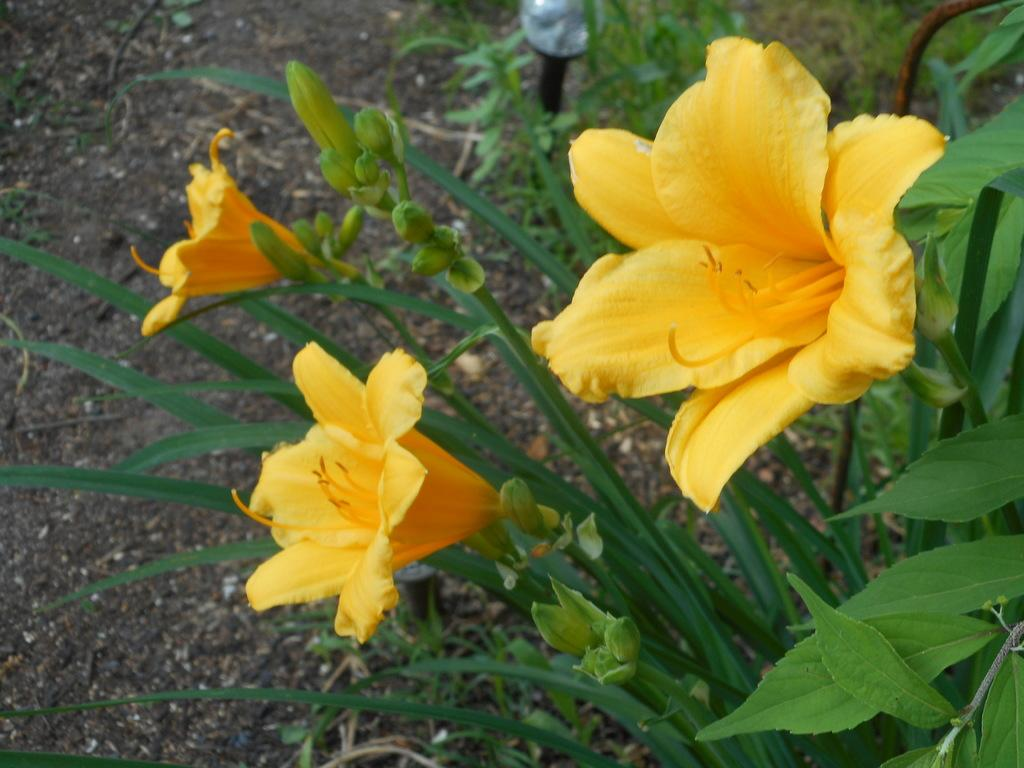What type of plants can be seen in the image? There are flowers in the image. What color are the flowers? The flowers are yellow. What other part of the plant is visible in the image? There are green leaves in the image. What type of camera is being used to take a picture of the flowers in the image? There is no camera visible in the image, and it is not mentioned that the flowers are being photographed. 